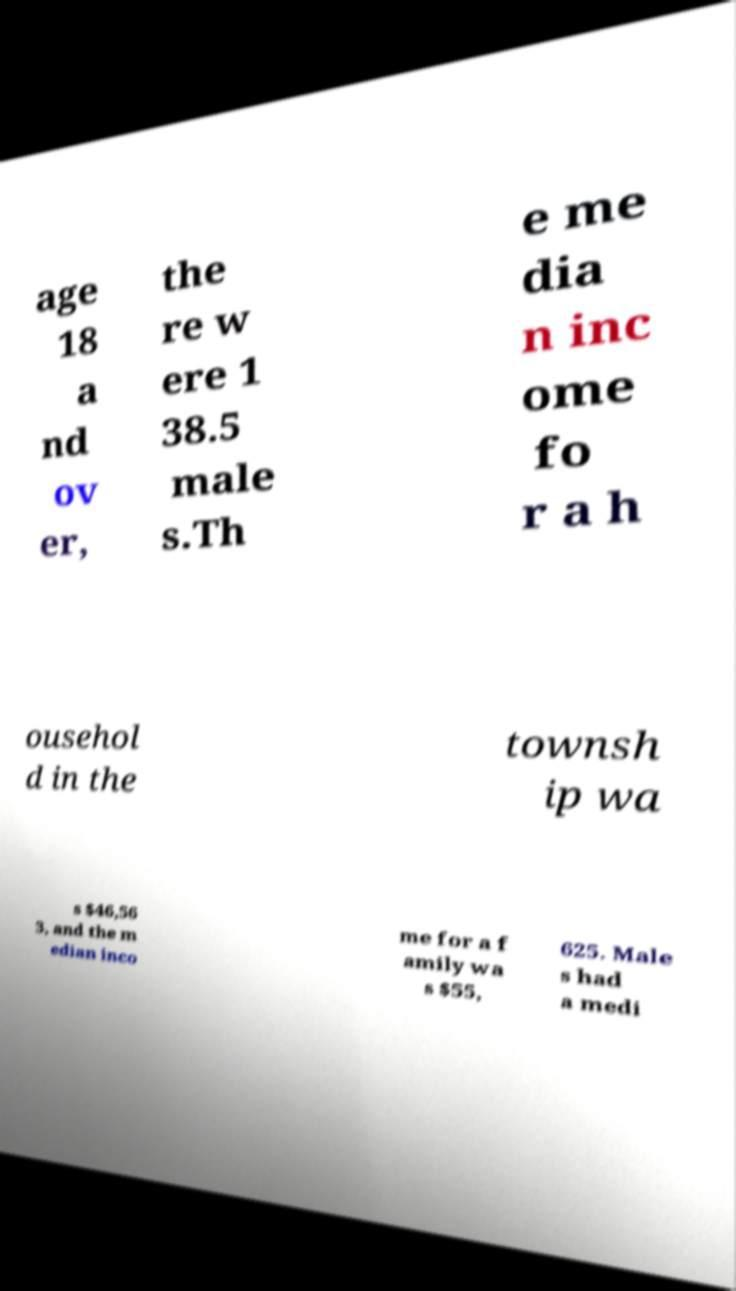Please read and relay the text visible in this image. What does it say? age 18 a nd ov er, the re w ere 1 38.5 male s.Th e me dia n inc ome fo r a h ousehol d in the townsh ip wa s $46,56 3, and the m edian inco me for a f amily wa s $55, 625. Male s had a medi 